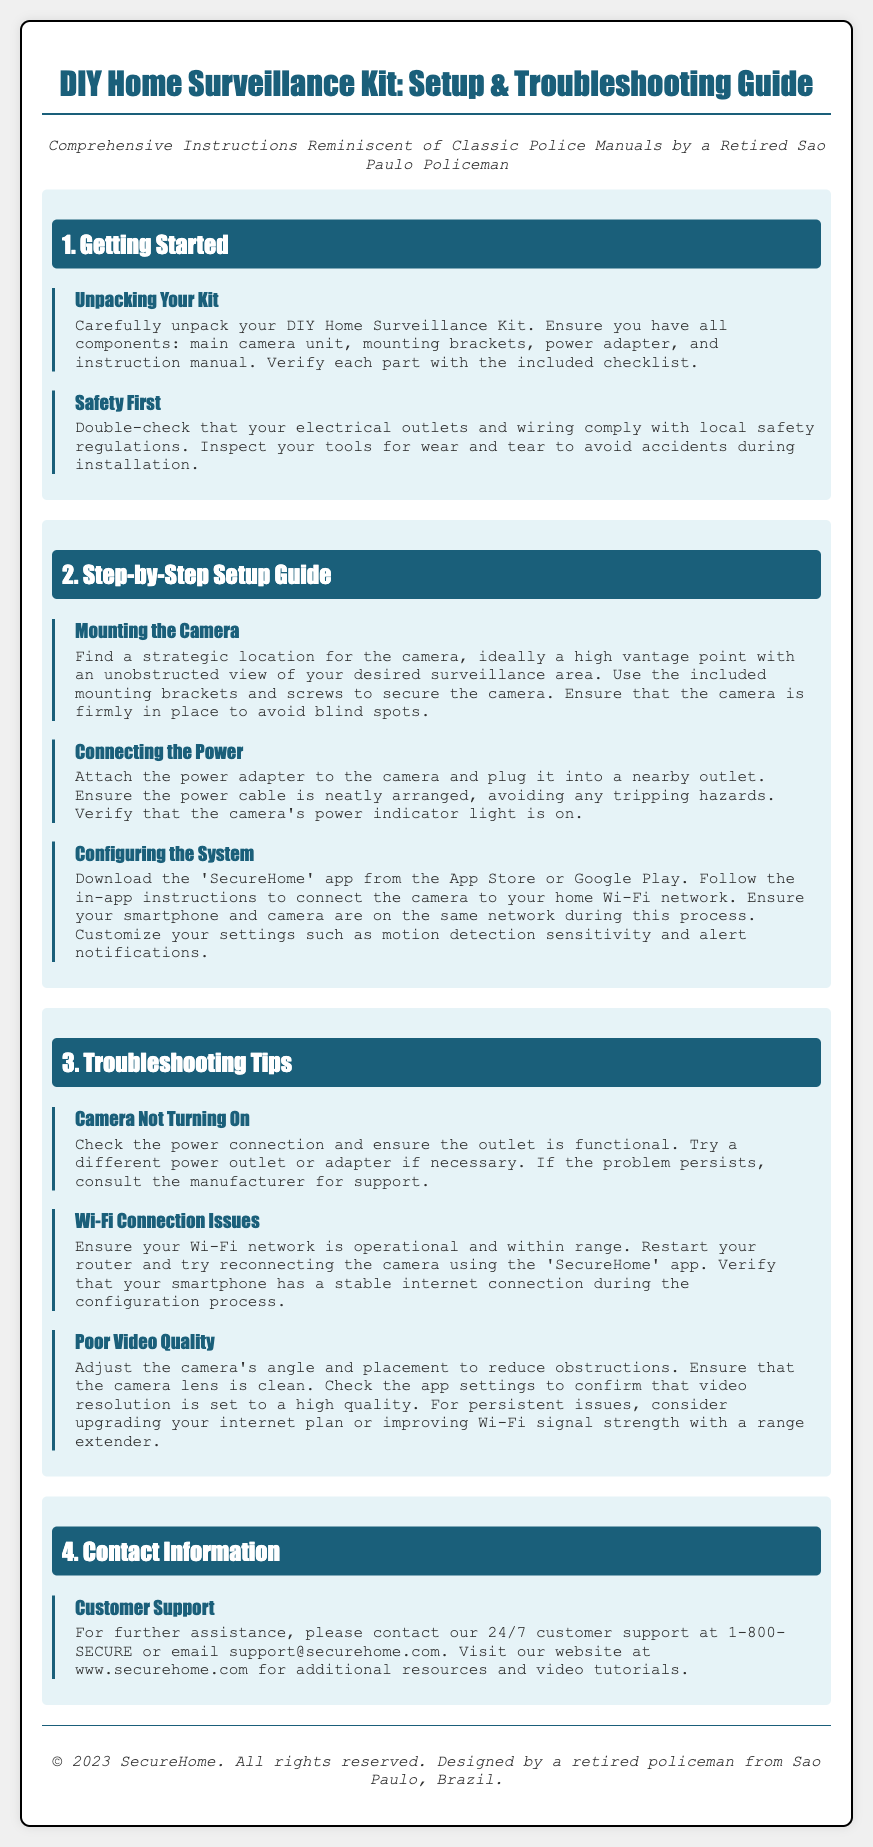What is the title of the guide? The title of the guide is mentioned at the top of the document.
Answer: DIY Home Surveillance Kit: Setup & Troubleshooting Guide How many sections are in the guide? The number of sections can be counted based on the headings provided in the document.
Answer: 4 What is the first step listed under "Step-by-Step Setup Guide"? This information is found in the section detailing the steps for setting up the surveillance kit.
Answer: Mounting the Camera What should you check if your camera does not turn on? The troubleshooting section suggests specific actions to take if the camera doesn't turn on.
Answer: Power connection What is the contact number for customer support? The contact information for customer support provides a specific number to call.
Answer: 1-800-SECURE What does the power adapter connect to? The setup instructions specify what the power adapter attaches to during installation.
Answer: The camera What app do you need to download for setup? The app needed for configuration is clearly stated in the setup guide section.
Answer: SecureHome What is the main color of the section headers? The visual design of the document indicates the color scheme used for section headers.
Answer: #1a5f7a What should you verify regarding your Wi-Fi network? The setup guide emphasizes a specific condition about the Wi-Fi that needs to be checked.
Answer: Operational and within range 